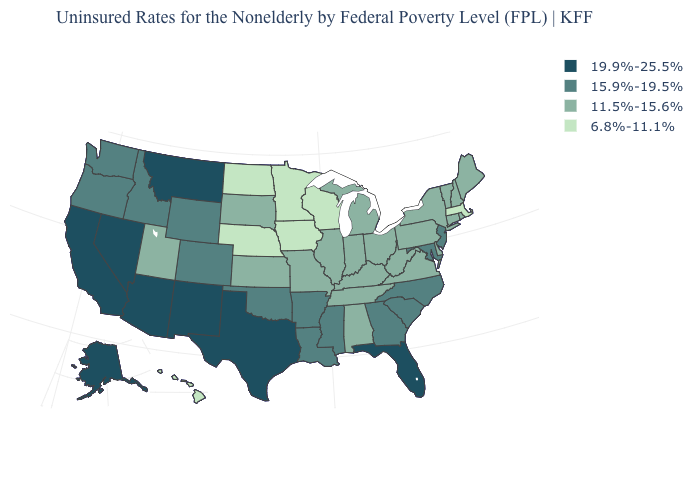What is the value of Maine?
Keep it brief. 11.5%-15.6%. Name the states that have a value in the range 6.8%-11.1%?
Concise answer only. Hawaii, Iowa, Massachusetts, Minnesota, Nebraska, North Dakota, Wisconsin. Among the states that border Kansas , which have the lowest value?
Keep it brief. Nebraska. What is the value of Florida?
Answer briefly. 19.9%-25.5%. Among the states that border Indiana , which have the highest value?
Write a very short answer. Illinois, Kentucky, Michigan, Ohio. Name the states that have a value in the range 6.8%-11.1%?
Write a very short answer. Hawaii, Iowa, Massachusetts, Minnesota, Nebraska, North Dakota, Wisconsin. Does Minnesota have a higher value than Maryland?
Short answer required. No. Which states have the lowest value in the USA?
Keep it brief. Hawaii, Iowa, Massachusetts, Minnesota, Nebraska, North Dakota, Wisconsin. Name the states that have a value in the range 11.5%-15.6%?
Give a very brief answer. Alabama, Connecticut, Delaware, Illinois, Indiana, Kansas, Kentucky, Maine, Michigan, Missouri, New Hampshire, New York, Ohio, Pennsylvania, Rhode Island, South Dakota, Tennessee, Utah, Vermont, Virginia, West Virginia. What is the value of Wisconsin?
Be succinct. 6.8%-11.1%. What is the highest value in the USA?
Be succinct. 19.9%-25.5%. How many symbols are there in the legend?
Give a very brief answer. 4. Name the states that have a value in the range 6.8%-11.1%?
Quick response, please. Hawaii, Iowa, Massachusetts, Minnesota, Nebraska, North Dakota, Wisconsin. Name the states that have a value in the range 6.8%-11.1%?
Keep it brief. Hawaii, Iowa, Massachusetts, Minnesota, Nebraska, North Dakota, Wisconsin. Does Connecticut have the highest value in the USA?
Answer briefly. No. 